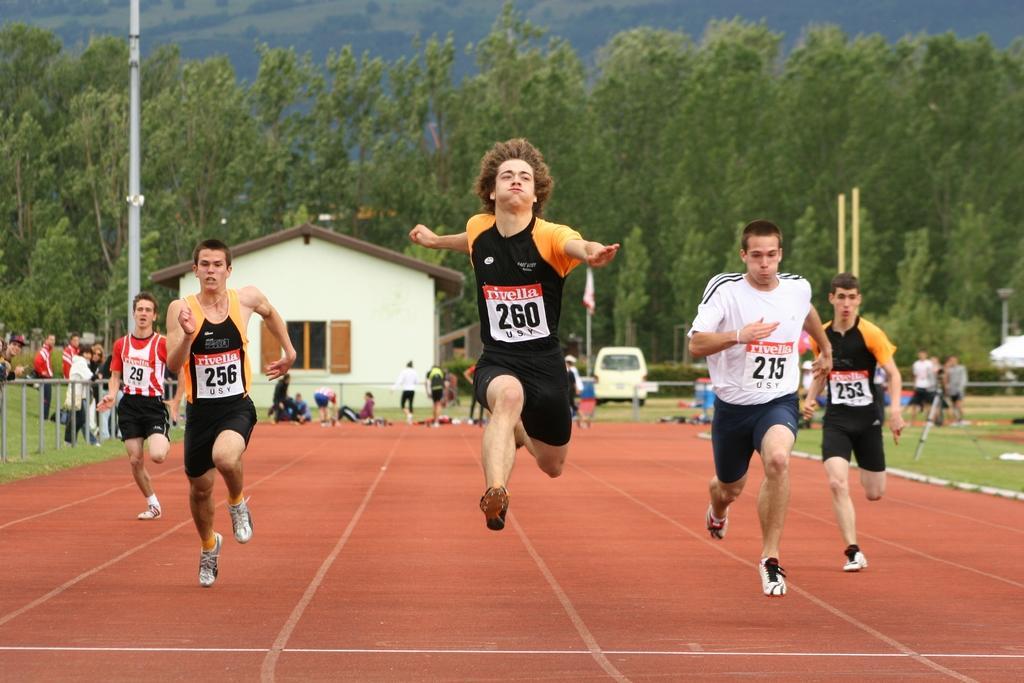In one or two sentences, can you explain what this image depicts? In this picture I can see few people running and few people are standing and few are seated on the ground and I can see trees and few poles and a flagpole and I can see trees and a house on the back and I can see a car parked. 